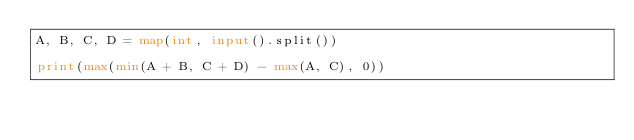<code> <loc_0><loc_0><loc_500><loc_500><_Python_>A, B, C, D = map(int, input().split())

print(max(min(A + B, C + D) - max(A, C), 0))</code> 